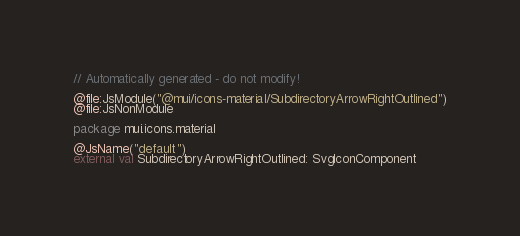<code> <loc_0><loc_0><loc_500><loc_500><_Kotlin_>// Automatically generated - do not modify!

@file:JsModule("@mui/icons-material/SubdirectoryArrowRightOutlined")
@file:JsNonModule

package mui.icons.material

@JsName("default")
external val SubdirectoryArrowRightOutlined: SvgIconComponent
</code> 